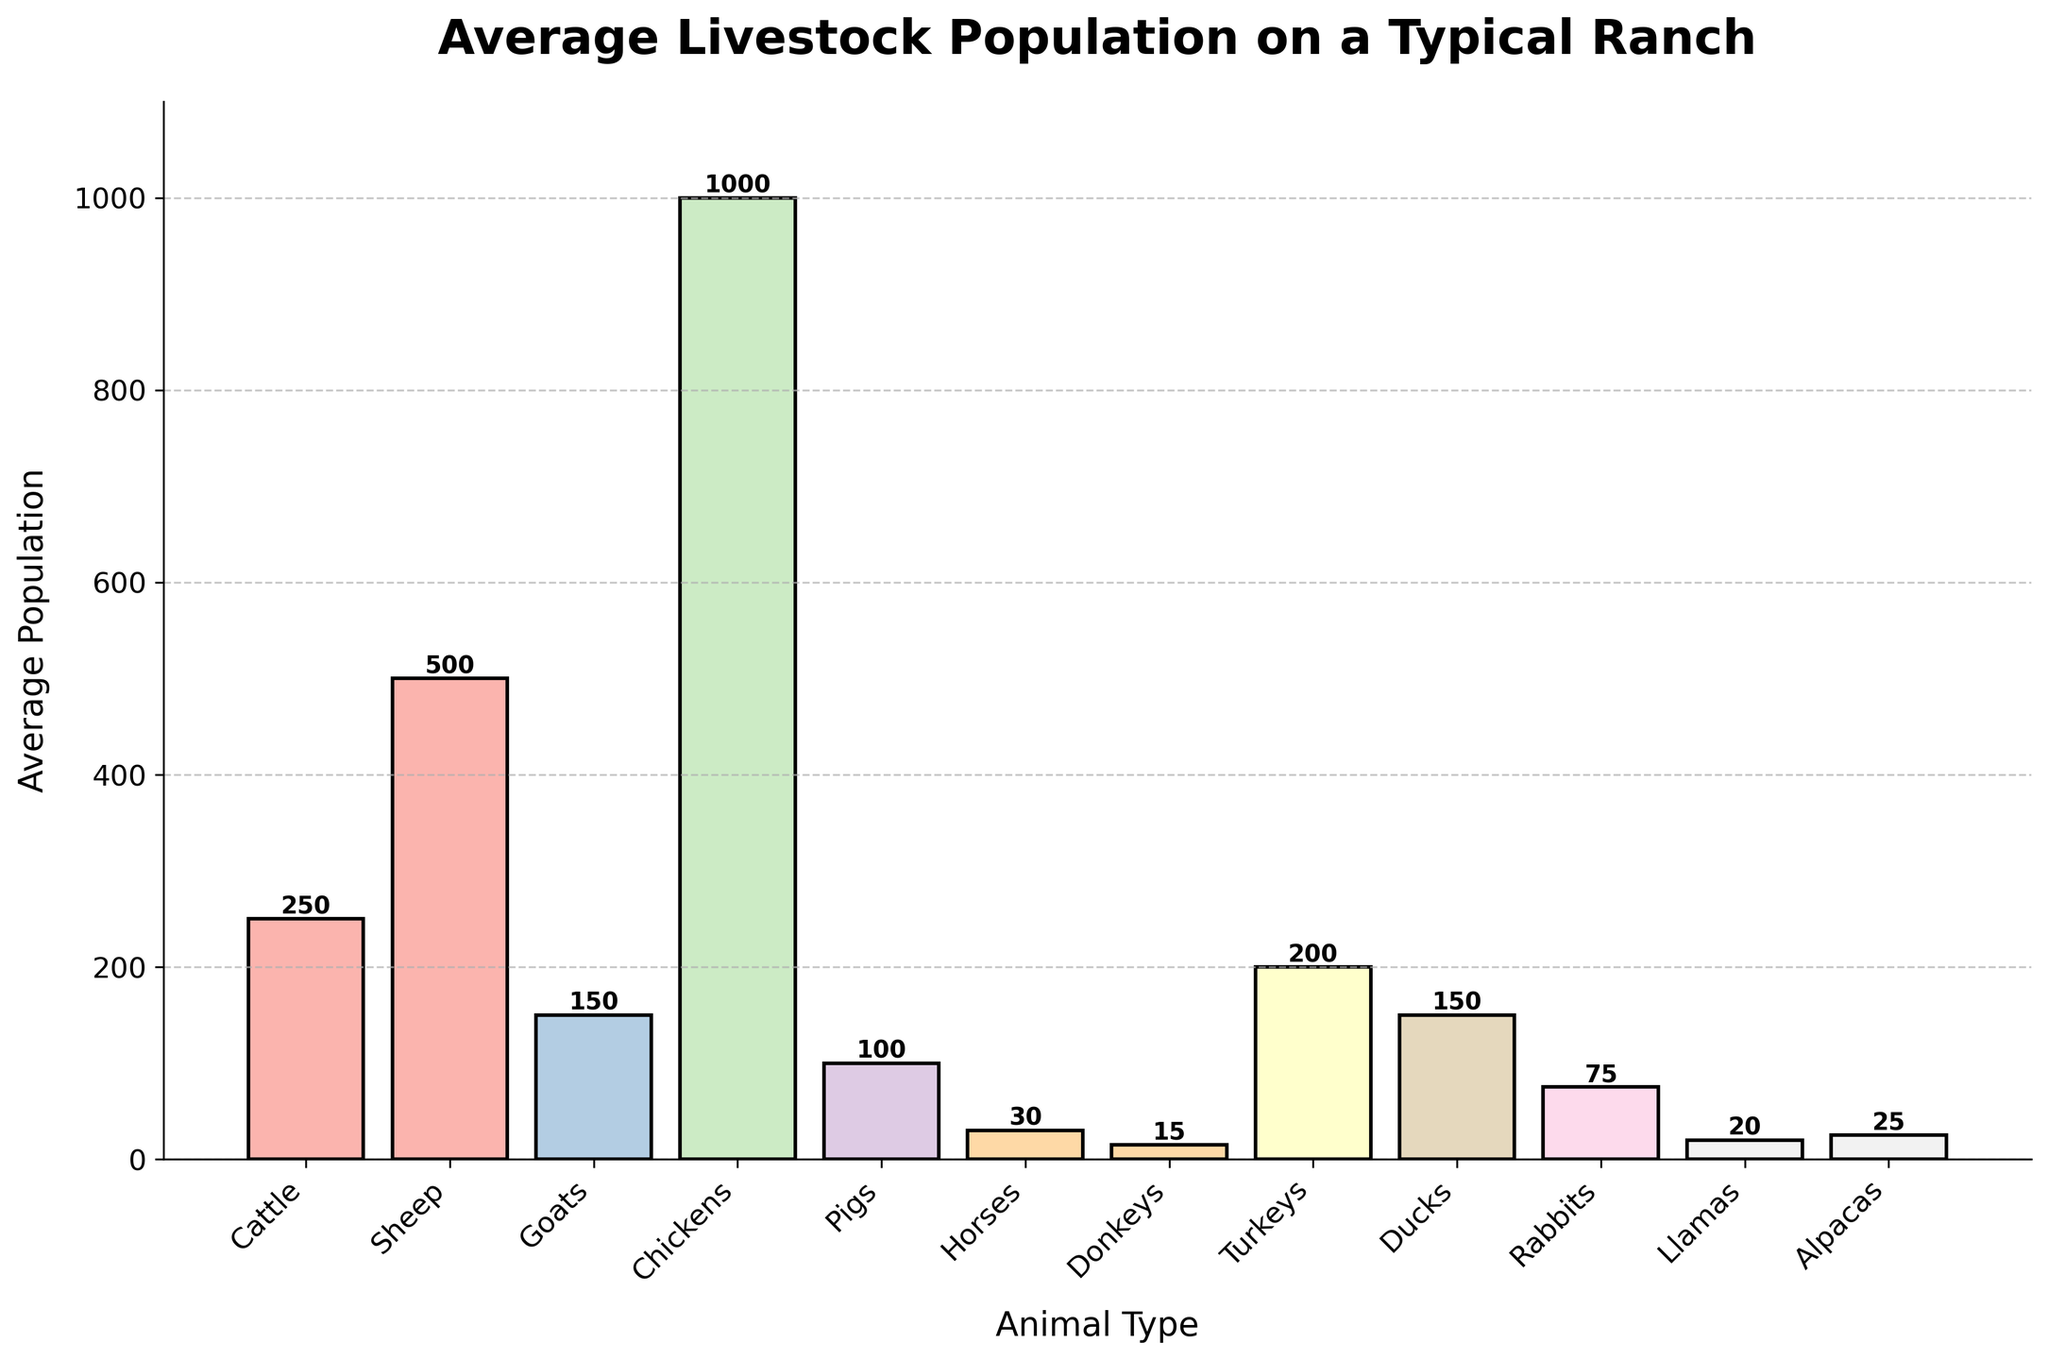What's the most numerous animal type on a typical ranch? According to the bar chart, the animal type with the tallest bar represents the most numerous animal. Here, the tallest bar is for 'Chickens'.
Answer: Chickens Which animal has a lower population, goats or turkeys? By comparing the heights of the bars for 'Goats' and 'Turkeys', we see that the bar for 'Goats' is shorter.
Answer: Goats What is the difference in population between sheep and ducks? The average population of sheep is 500 and the average population of ducks is 150. Subtracting these values gives 500 - 150 = 350.
Answer: 350 Are there more rabbits or donkeys on a typical ranch? The bar for 'Rabbits' is taller than the bar for 'Donkeys', indicating that the average population of rabbits is higher.
Answer: Rabbits What is the total population of horses, llamas, and alpacas combined? Adding the average populations of horses (30), llamas (20), and alpacas (25) gives 30 + 20 + 25 = 75.
Answer: 75 Which animals have a population greater than 200? By examining the height of the bars, we can see that the average populations of 'Chickens' and 'Sheep' are both greater than 200.
Answer: Chickens, Sheep What's the average population of cattle, pigs, and turkeys? Summing the average populations of cattle (250), pigs (100), and turkeys (200) and then dividing by 3 gives (250 + 100 + 200) / 3 = 183.33.
Answer: 183.33 Which has a higher population, ducks or goats? Comparing the bar heights for 'Ducks' and 'Goats' shows that the bar for ducks is slightly taller.
Answer: Ducks What is the combined population of the three least numerous animals? The three least numerous animals are 'Donkeys' (15), 'Llamas' (20), and 'Alpacas' (25). Adding these gives 15 + 20 + 25 = 60.
Answer: 60 Is the combined population of rabbits and ducks greater than that of chickens? Adding the populations of rabbits (75) and ducks (150) gives 75 + 150 = 225, which is less than the population of chickens (1000).
Answer: No 